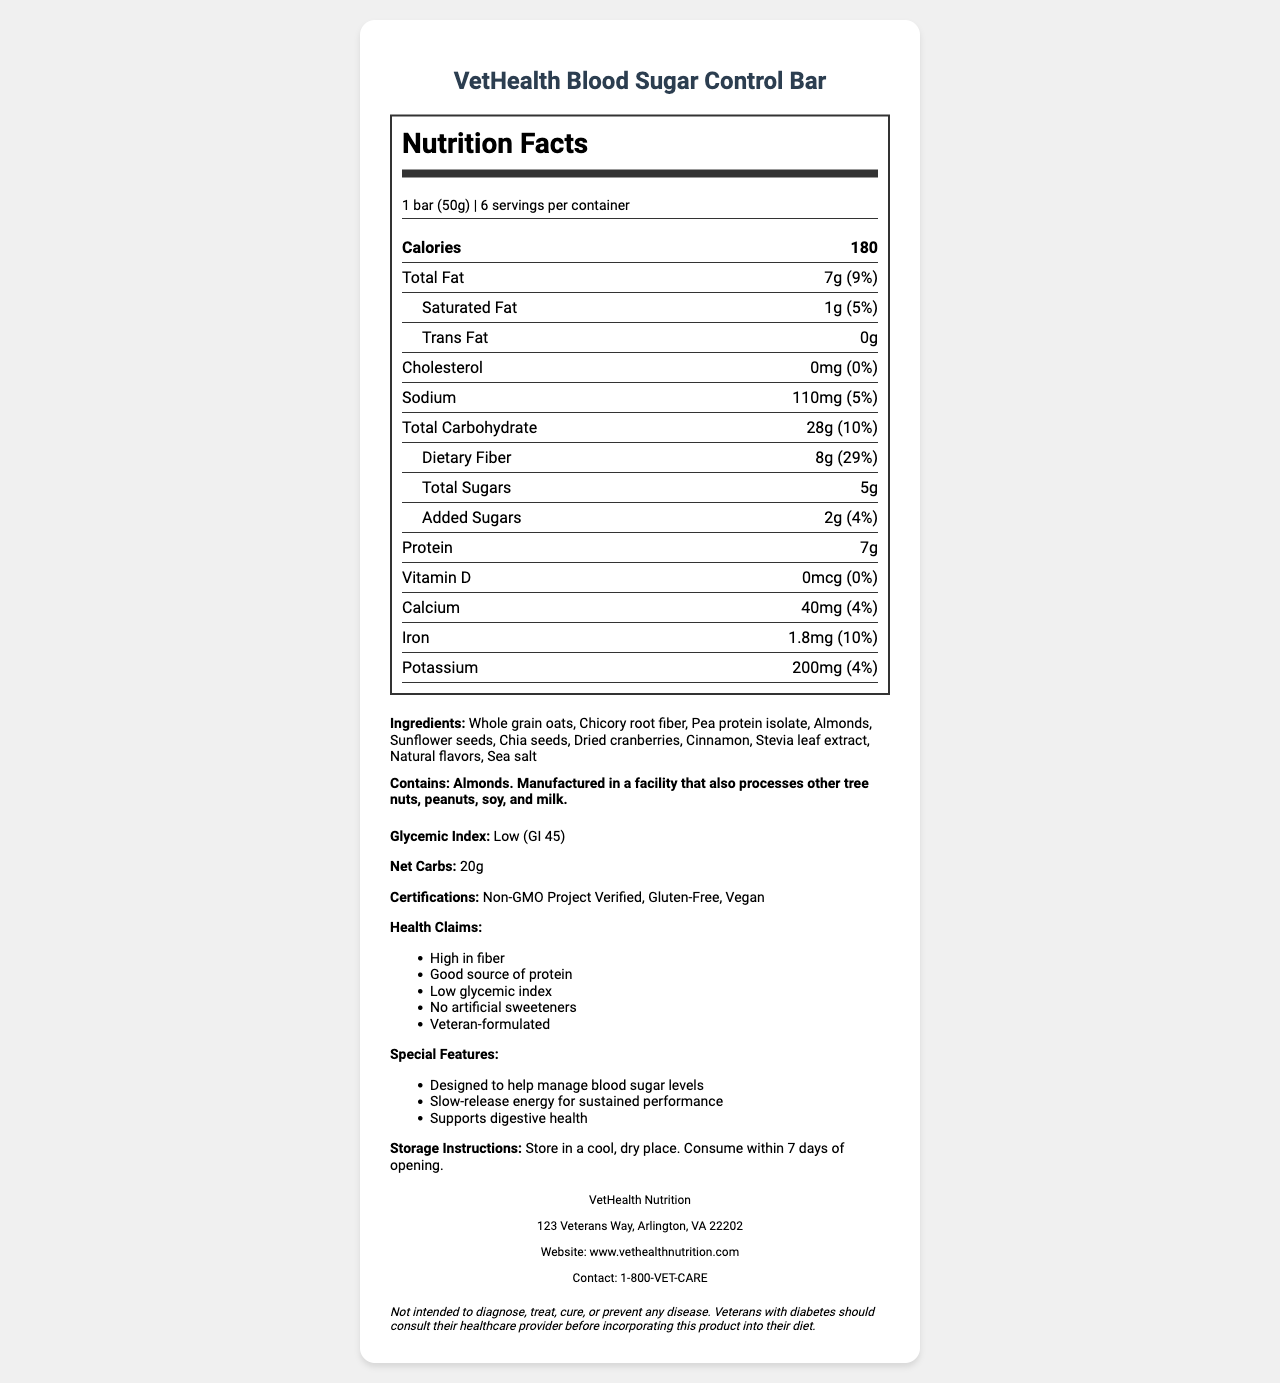what is the serving size of the VetHealth Blood Sugar Control Bar? The serving size is clearly stated as 1 bar weighing 50g.
Answer: 1 bar (50g) how many calories are in one serving of the VetHealth Blood Sugar Control Bar? The label lists the calorie content per serving as 180.
Answer: 180 calories what percentage of the daily value does the dietary fiber in one serving of the bar provide? The label indicates that the dietary fiber in one serving is 8g, which corresponds to 29% of the daily value.
Answer: 29% what is the total carbohydrate content per serving? The total carbohydrate content per serving is stated as 28g on the label.
Answer: 28g are there any trans fats in the VetHealth Blood Sugar Control Bar? The label shows that the trans fat content is 0g.
Answer: No how much sodium is in each serving and what is its percent daily value? Each serving contains 110mg of sodium, which is 5% of the daily value.
Answer: 110mg (5%) what are the top three ingredients listed for the VetHealth Blood Sugar Control Bar? The first three ingredients listed are Whole grain oats, Chicory root fiber, and Pea protein isolate.
Answer: Whole grain oats, Chicory root fiber, Pea protein isolate which certification does NOT apply to the VetHealth Blood Sugar Control Bar? A. Non-GMO Project Verified B. Kosher Certified C. Gluten-Free The bar is Non-GMO Project Verified, Gluten-Free, and Vegan, but Kosher Certified is not listed.
Answer: B. Kosher Certified which special feature is mentioned for the VetHealth Blood Sugar Control Bar? A. Supports eye health B. Supports weight management C. Supports digestive health One of the special features mentioned is that it supports digestive health.
Answer: C. Supports digestive health is chia seed listed as an ingredient in the VetHealth Blood Sugar Control Bar? The document lists chia seeds as one of the ingredients.
Answer: Yes how many bars are in one container of the VetHealth Blood Sugar Control Bar? The document states that there are 6 servings per container, indicating 6 bars.
Answer: 6 bars does the VetHealth Blood Sugar Control Bar contain any artificial sweeteners? The label claims there are no artificial sweeteners in the product.
Answer: No describe the main health benefits of consuming the VetHealth Blood Sugar Control Bar. This summary captures the key health benefits mentioned in the document, focusing on fiber content, protein, glycemic index, absence of artificial sweeteners, and special features.
Answer: The VetHealth Blood Sugar Control Bar is high in fiber and a good source of protein, has a low glycemic index, and contains no artificial sweeteners. It's also designed to help manage blood sugar levels, provide slow-release energy for sustained performance, and support digestive health. where is the VetHealth Nutrition company located? The manufacturer info contains the address: 123 Veterans Way, Arlington, VA 22202.
Answer: 123 Veterans Way, Arlington, VA 22202 are the bars suitable for vegetarians? The bar is labeled as Vegan, which implies it is suitable for vegetarians.
Answer: Yes what is the glycemic index of the VetHealth Blood Sugar Control Bar? The glycemic index is stated as Low (GI 45) in the additional info section.
Answer: Low (GI 45) what should veterans with diabetes do before incorporating this product into their diet? The disclaimer advises veterans with diabetes to consult their healthcare provider before incorporating this product into their diet.
Answer: Consult their healthcare provider can you determine the production date of the VetHealth Blood Sugar Control Bar from the document? The document does not provide any details regarding the production date of the bars.
Answer: Not enough information 